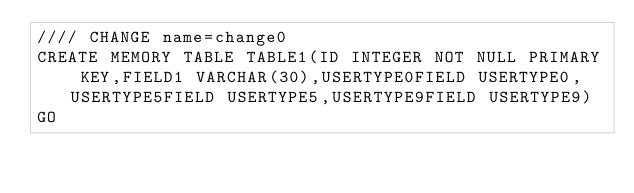Convert code to text. <code><loc_0><loc_0><loc_500><loc_500><_SQL_>//// CHANGE name=change0
CREATE MEMORY TABLE TABLE1(ID INTEGER NOT NULL PRIMARY KEY,FIELD1 VARCHAR(30),USERTYPE0FIELD USERTYPE0,USERTYPE5FIELD USERTYPE5,USERTYPE9FIELD USERTYPE9)
GO
</code> 